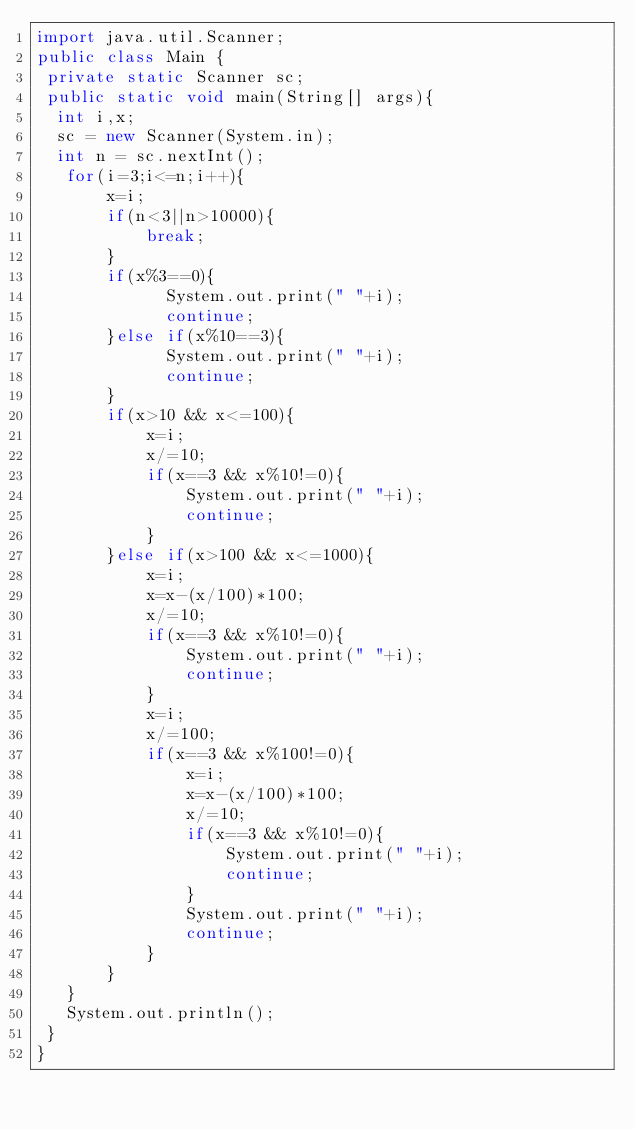<code> <loc_0><loc_0><loc_500><loc_500><_Java_>import java.util.Scanner;
public class Main {
 private static Scanner sc;
 public static void main(String[] args){
  int i,x;
  sc = new Scanner(System.in);
  int n = sc.nextInt();
   for(i=3;i<=n;i++){
	   x=i;
	   if(n<3||n>10000){
		   break;
	   }
       if(x%3==0){
    	     System.out.print(" "+i);
    	     continue;
       }else if(x%10==3){
    	     System.out.print(" "+i);
    	     continue;
       }
       if(x>10 && x<=100){
    	   x=i;
           x/=10;
           if(x==3 && x%10!=0){
        	   System.out.print(" "+i);
        	   continue;
           }
       }else if(x>100 && x<=1000){
    	   x=i;
           x=x-(x/100)*100;
           x/=10;
           if(x==3 && x%10!=0){
        	   System.out.print(" "+i);
        	   continue;
           }
           x=i;
           x/=100;
           if(x==3 && x%100!=0){
        	   x=i;
               x=x-(x/100)*100;
               x/=10;
               if(x==3 && x%10!=0){
            	   System.out.print(" "+i);
            	   continue;
               }
        	   System.out.print(" "+i);
        	   continue;
           }
       }
   }
   System.out.println();
 }
}</code> 